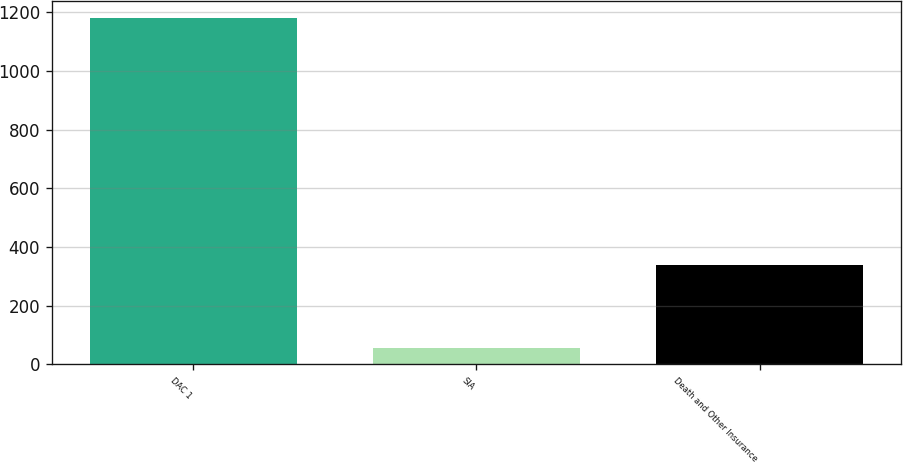<chart> <loc_0><loc_0><loc_500><loc_500><bar_chart><fcel>DAC 1<fcel>SIA<fcel>Death and Other Insurance<nl><fcel>1180<fcel>56<fcel>340<nl></chart> 